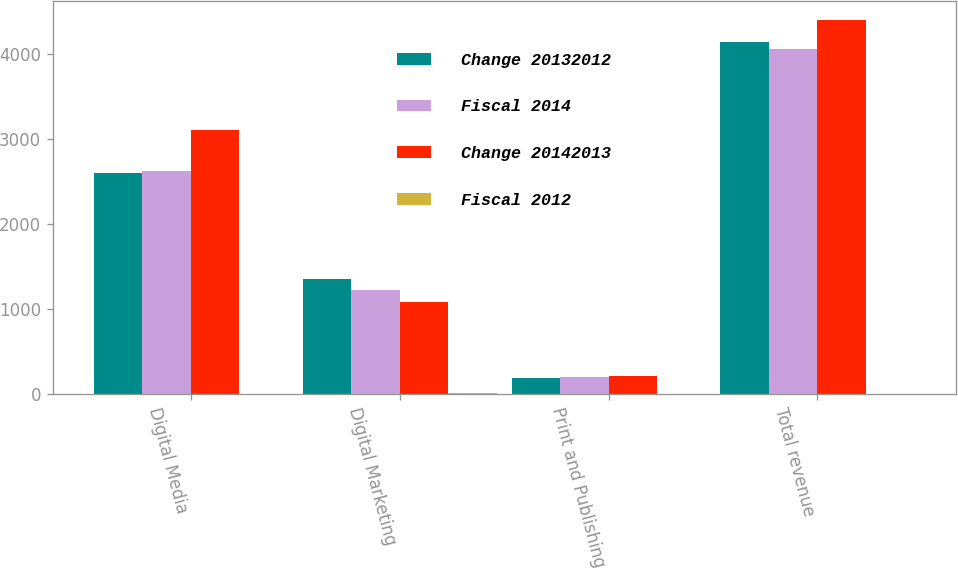Convert chart. <chart><loc_0><loc_0><loc_500><loc_500><stacked_bar_chart><ecel><fcel>Digital Media<fcel>Digital Marketing<fcel>Print and Publishing<fcel>Total revenue<nl><fcel>Change 20132012<fcel>2603.2<fcel>1355.2<fcel>188.7<fcel>4147.1<nl><fcel>Fiscal 2014<fcel>2625.9<fcel>1228.8<fcel>200.5<fcel>4055.2<nl><fcel>Change 20142013<fcel>3101.9<fcel>1085<fcel>216.8<fcel>4403.7<nl><fcel>Fiscal 2012<fcel>1<fcel>10<fcel>6<fcel>2<nl></chart> 